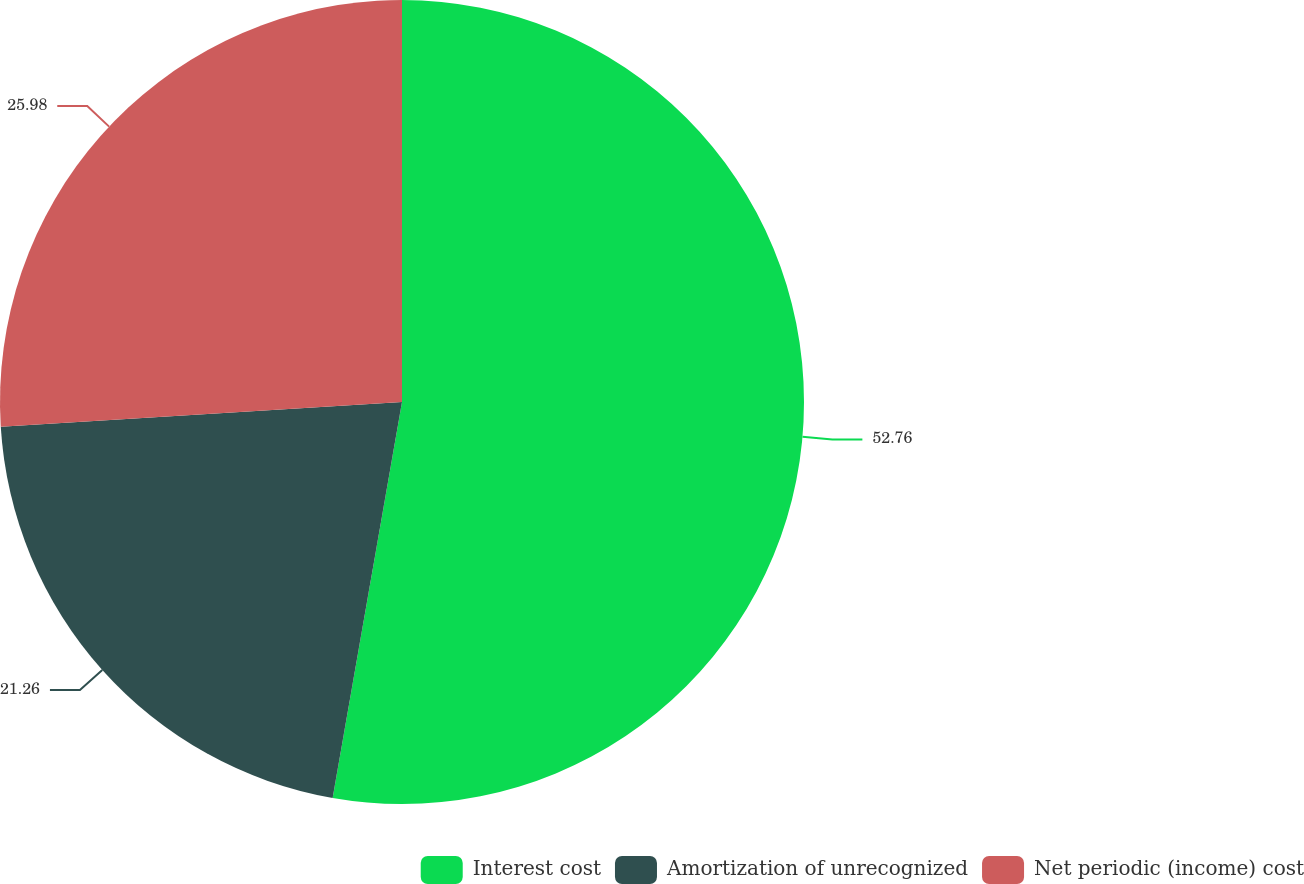Convert chart. <chart><loc_0><loc_0><loc_500><loc_500><pie_chart><fcel>Interest cost<fcel>Amortization of unrecognized<fcel>Net periodic (income) cost<nl><fcel>52.76%<fcel>21.26%<fcel>25.98%<nl></chart> 